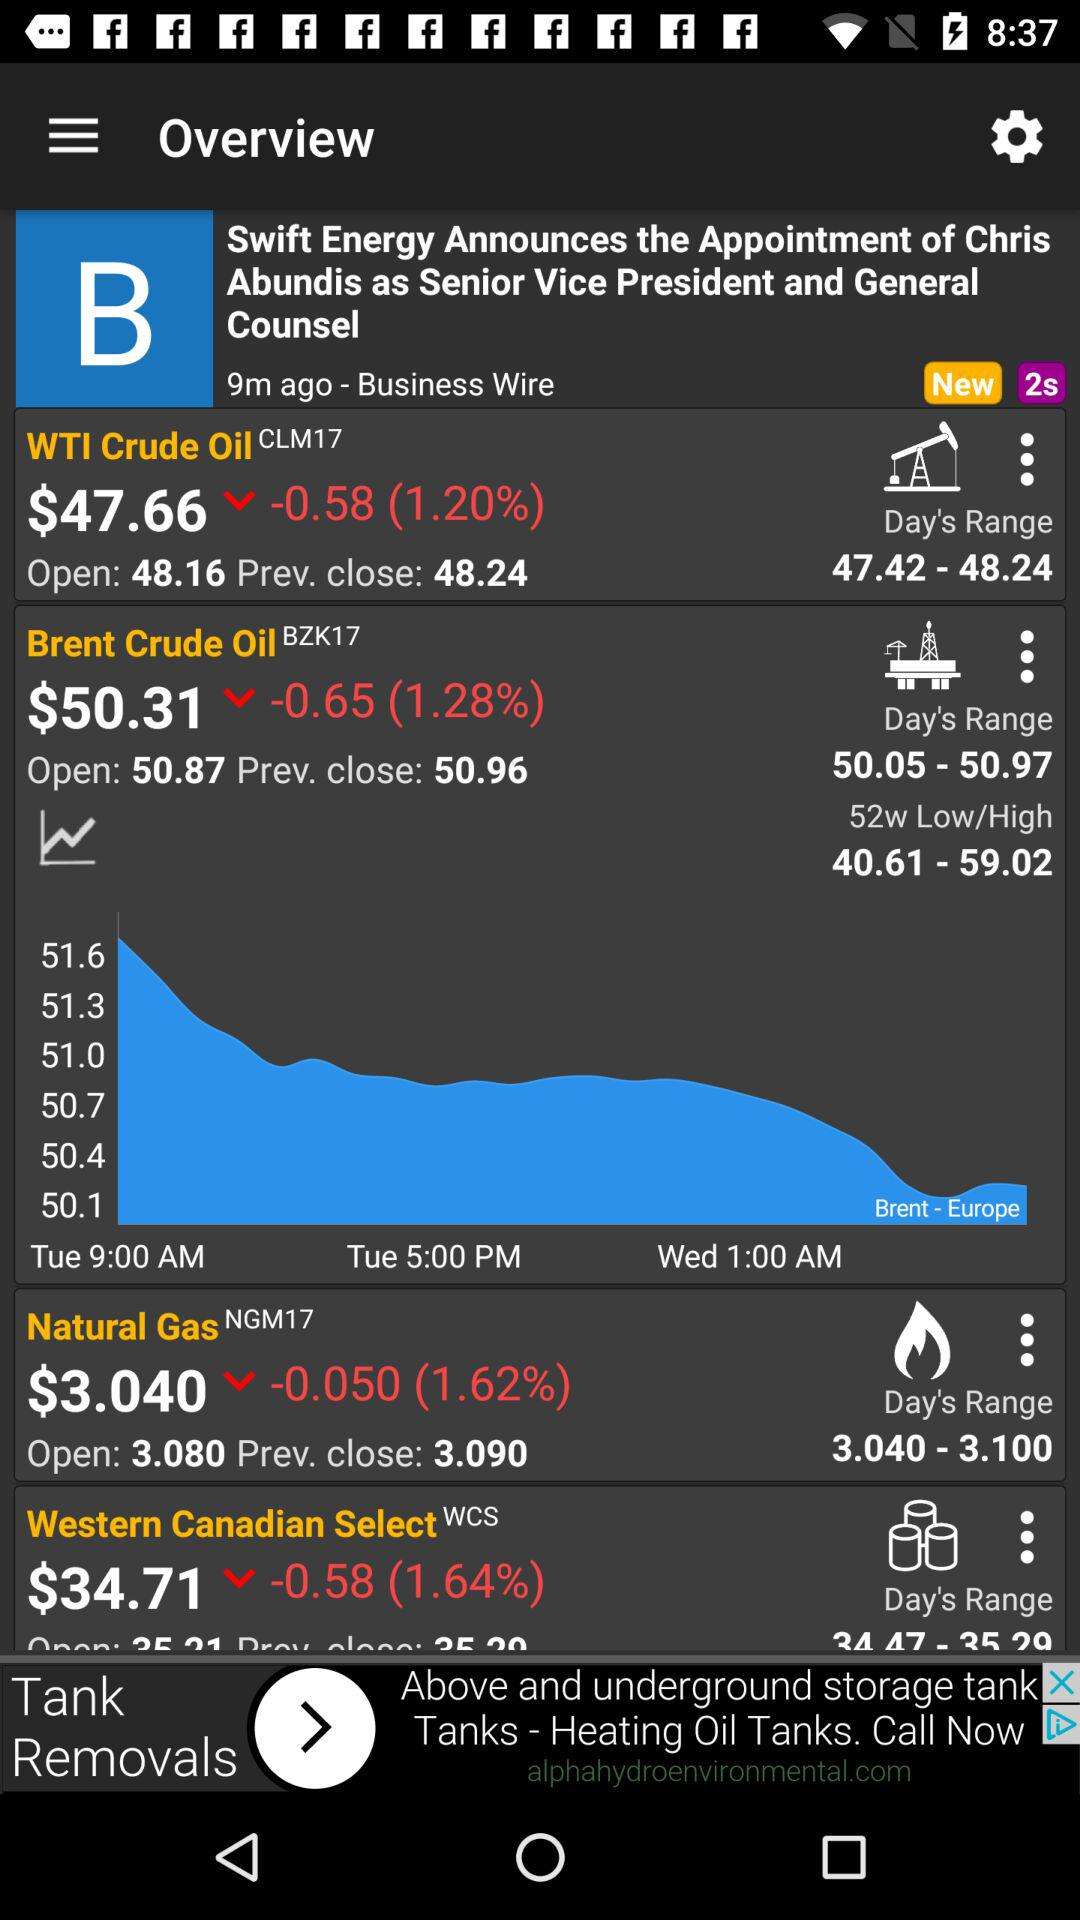Who is appointed as Senior Vice President and General Counsel? The person who is appointed as Senior Vice President and General Counsel is Chris Abundis. 